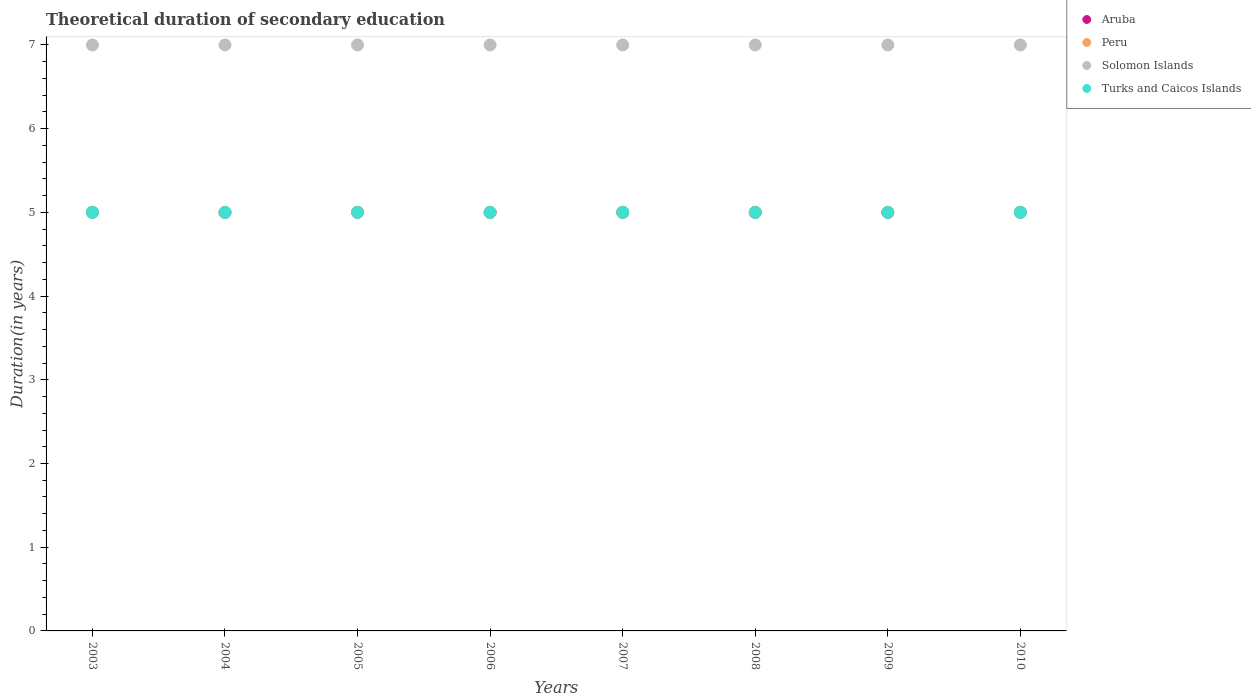How many different coloured dotlines are there?
Provide a short and direct response. 4. What is the total theoretical duration of secondary education in Turks and Caicos Islands in 2007?
Your answer should be compact. 5. Across all years, what is the maximum total theoretical duration of secondary education in Turks and Caicos Islands?
Your response must be concise. 5. Across all years, what is the minimum total theoretical duration of secondary education in Peru?
Ensure brevity in your answer.  5. In which year was the total theoretical duration of secondary education in Solomon Islands maximum?
Your answer should be compact. 2003. What is the total total theoretical duration of secondary education in Peru in the graph?
Offer a very short reply. 40. What is the difference between the total theoretical duration of secondary education in Turks and Caicos Islands in 2003 and that in 2007?
Keep it short and to the point. 0. What is the average total theoretical duration of secondary education in Peru per year?
Your response must be concise. 5. What is the ratio of the total theoretical duration of secondary education in Aruba in 2003 to that in 2006?
Provide a succinct answer. 1. Is it the case that in every year, the sum of the total theoretical duration of secondary education in Peru and total theoretical duration of secondary education in Turks and Caicos Islands  is greater than the sum of total theoretical duration of secondary education in Solomon Islands and total theoretical duration of secondary education in Aruba?
Your answer should be very brief. No. Does the total theoretical duration of secondary education in Solomon Islands monotonically increase over the years?
Your answer should be compact. No. Is the total theoretical duration of secondary education in Peru strictly greater than the total theoretical duration of secondary education in Aruba over the years?
Your answer should be compact. No. Is the total theoretical duration of secondary education in Solomon Islands strictly less than the total theoretical duration of secondary education in Peru over the years?
Keep it short and to the point. No. How many dotlines are there?
Provide a short and direct response. 4. How many years are there in the graph?
Keep it short and to the point. 8. What is the difference between two consecutive major ticks on the Y-axis?
Your answer should be very brief. 1. Are the values on the major ticks of Y-axis written in scientific E-notation?
Your answer should be compact. No. Where does the legend appear in the graph?
Give a very brief answer. Top right. How many legend labels are there?
Provide a short and direct response. 4. What is the title of the graph?
Offer a very short reply. Theoretical duration of secondary education. Does "High income" appear as one of the legend labels in the graph?
Keep it short and to the point. No. What is the label or title of the Y-axis?
Your answer should be compact. Duration(in years). What is the Duration(in years) of Aruba in 2003?
Your answer should be very brief. 5. What is the Duration(in years) of Solomon Islands in 2003?
Your answer should be very brief. 7. What is the Duration(in years) of Turks and Caicos Islands in 2003?
Offer a terse response. 5. What is the Duration(in years) in Peru in 2004?
Offer a very short reply. 5. What is the Duration(in years) in Turks and Caicos Islands in 2004?
Provide a short and direct response. 5. What is the Duration(in years) of Aruba in 2005?
Offer a very short reply. 5. What is the Duration(in years) in Peru in 2005?
Provide a short and direct response. 5. What is the Duration(in years) in Solomon Islands in 2005?
Make the answer very short. 7. What is the Duration(in years) of Turks and Caicos Islands in 2005?
Keep it short and to the point. 5. What is the Duration(in years) in Aruba in 2006?
Your response must be concise. 5. What is the Duration(in years) of Peru in 2006?
Keep it short and to the point. 5. What is the Duration(in years) of Turks and Caicos Islands in 2006?
Ensure brevity in your answer.  5. What is the Duration(in years) of Solomon Islands in 2007?
Ensure brevity in your answer.  7. What is the Duration(in years) of Peru in 2008?
Keep it short and to the point. 5. What is the Duration(in years) in Solomon Islands in 2008?
Provide a short and direct response. 7. What is the Duration(in years) of Turks and Caicos Islands in 2008?
Provide a short and direct response. 5. What is the Duration(in years) of Peru in 2009?
Offer a terse response. 5. What is the Duration(in years) of Solomon Islands in 2009?
Offer a very short reply. 7. What is the Duration(in years) in Turks and Caicos Islands in 2009?
Ensure brevity in your answer.  5. What is the Duration(in years) of Peru in 2010?
Offer a terse response. 5. What is the Duration(in years) in Solomon Islands in 2010?
Offer a terse response. 7. What is the Duration(in years) of Turks and Caicos Islands in 2010?
Provide a short and direct response. 5. Across all years, what is the maximum Duration(in years) of Aruba?
Offer a very short reply. 5. Across all years, what is the maximum Duration(in years) in Peru?
Your answer should be very brief. 5. Across all years, what is the maximum Duration(in years) in Turks and Caicos Islands?
Offer a very short reply. 5. Across all years, what is the minimum Duration(in years) of Peru?
Provide a short and direct response. 5. Across all years, what is the minimum Duration(in years) of Solomon Islands?
Offer a terse response. 7. What is the total Duration(in years) of Peru in the graph?
Provide a short and direct response. 40. What is the difference between the Duration(in years) in Aruba in 2003 and that in 2004?
Provide a short and direct response. 0. What is the difference between the Duration(in years) of Solomon Islands in 2003 and that in 2004?
Provide a short and direct response. 0. What is the difference between the Duration(in years) in Aruba in 2003 and that in 2005?
Make the answer very short. 0. What is the difference between the Duration(in years) in Solomon Islands in 2003 and that in 2005?
Provide a succinct answer. 0. What is the difference between the Duration(in years) of Turks and Caicos Islands in 2003 and that in 2005?
Provide a short and direct response. 0. What is the difference between the Duration(in years) of Aruba in 2003 and that in 2006?
Your answer should be compact. 0. What is the difference between the Duration(in years) in Solomon Islands in 2003 and that in 2006?
Ensure brevity in your answer.  0. What is the difference between the Duration(in years) in Turks and Caicos Islands in 2003 and that in 2006?
Give a very brief answer. 0. What is the difference between the Duration(in years) of Turks and Caicos Islands in 2003 and that in 2007?
Give a very brief answer. 0. What is the difference between the Duration(in years) in Aruba in 2003 and that in 2008?
Offer a terse response. 0. What is the difference between the Duration(in years) of Peru in 2003 and that in 2008?
Make the answer very short. 0. What is the difference between the Duration(in years) in Aruba in 2003 and that in 2009?
Your answer should be very brief. 0. What is the difference between the Duration(in years) of Peru in 2003 and that in 2009?
Your answer should be very brief. 0. What is the difference between the Duration(in years) of Solomon Islands in 2003 and that in 2009?
Provide a short and direct response. 0. What is the difference between the Duration(in years) in Peru in 2003 and that in 2010?
Ensure brevity in your answer.  0. What is the difference between the Duration(in years) of Solomon Islands in 2003 and that in 2010?
Your answer should be very brief. 0. What is the difference between the Duration(in years) of Turks and Caicos Islands in 2003 and that in 2010?
Provide a short and direct response. 0. What is the difference between the Duration(in years) in Aruba in 2004 and that in 2005?
Offer a very short reply. 0. What is the difference between the Duration(in years) in Solomon Islands in 2004 and that in 2005?
Your answer should be very brief. 0. What is the difference between the Duration(in years) of Turks and Caicos Islands in 2004 and that in 2005?
Keep it short and to the point. 0. What is the difference between the Duration(in years) of Aruba in 2004 and that in 2006?
Make the answer very short. 0. What is the difference between the Duration(in years) in Turks and Caicos Islands in 2004 and that in 2006?
Offer a terse response. 0. What is the difference between the Duration(in years) in Aruba in 2004 and that in 2007?
Give a very brief answer. 0. What is the difference between the Duration(in years) in Peru in 2004 and that in 2007?
Provide a short and direct response. 0. What is the difference between the Duration(in years) of Turks and Caicos Islands in 2004 and that in 2007?
Your answer should be compact. 0. What is the difference between the Duration(in years) of Turks and Caicos Islands in 2004 and that in 2008?
Ensure brevity in your answer.  0. What is the difference between the Duration(in years) in Aruba in 2004 and that in 2009?
Your response must be concise. 0. What is the difference between the Duration(in years) in Peru in 2004 and that in 2009?
Offer a very short reply. 0. What is the difference between the Duration(in years) in Turks and Caicos Islands in 2004 and that in 2009?
Keep it short and to the point. 0. What is the difference between the Duration(in years) of Solomon Islands in 2004 and that in 2010?
Give a very brief answer. 0. What is the difference between the Duration(in years) in Aruba in 2005 and that in 2006?
Provide a succinct answer. 0. What is the difference between the Duration(in years) of Solomon Islands in 2005 and that in 2006?
Offer a very short reply. 0. What is the difference between the Duration(in years) in Turks and Caicos Islands in 2005 and that in 2006?
Your answer should be very brief. 0. What is the difference between the Duration(in years) of Peru in 2005 and that in 2007?
Make the answer very short. 0. What is the difference between the Duration(in years) of Aruba in 2005 and that in 2008?
Keep it short and to the point. 0. What is the difference between the Duration(in years) in Turks and Caicos Islands in 2005 and that in 2008?
Provide a succinct answer. 0. What is the difference between the Duration(in years) in Solomon Islands in 2005 and that in 2009?
Provide a succinct answer. 0. What is the difference between the Duration(in years) in Turks and Caicos Islands in 2005 and that in 2009?
Give a very brief answer. 0. What is the difference between the Duration(in years) of Aruba in 2005 and that in 2010?
Provide a succinct answer. 0. What is the difference between the Duration(in years) in Solomon Islands in 2005 and that in 2010?
Provide a short and direct response. 0. What is the difference between the Duration(in years) in Peru in 2006 and that in 2007?
Your answer should be very brief. 0. What is the difference between the Duration(in years) of Solomon Islands in 2006 and that in 2007?
Make the answer very short. 0. What is the difference between the Duration(in years) in Turks and Caicos Islands in 2006 and that in 2007?
Your answer should be very brief. 0. What is the difference between the Duration(in years) in Aruba in 2006 and that in 2008?
Provide a short and direct response. 0. What is the difference between the Duration(in years) of Peru in 2006 and that in 2008?
Make the answer very short. 0. What is the difference between the Duration(in years) of Turks and Caicos Islands in 2006 and that in 2008?
Ensure brevity in your answer.  0. What is the difference between the Duration(in years) of Peru in 2006 and that in 2009?
Your response must be concise. 0. What is the difference between the Duration(in years) in Solomon Islands in 2006 and that in 2009?
Give a very brief answer. 0. What is the difference between the Duration(in years) of Aruba in 2006 and that in 2010?
Ensure brevity in your answer.  0. What is the difference between the Duration(in years) in Peru in 2006 and that in 2010?
Your answer should be very brief. 0. What is the difference between the Duration(in years) in Aruba in 2007 and that in 2008?
Keep it short and to the point. 0. What is the difference between the Duration(in years) of Solomon Islands in 2007 and that in 2008?
Your answer should be very brief. 0. What is the difference between the Duration(in years) of Aruba in 2007 and that in 2009?
Keep it short and to the point. 0. What is the difference between the Duration(in years) of Turks and Caicos Islands in 2007 and that in 2009?
Your answer should be compact. 0. What is the difference between the Duration(in years) of Peru in 2007 and that in 2010?
Offer a terse response. 0. What is the difference between the Duration(in years) in Solomon Islands in 2007 and that in 2010?
Offer a very short reply. 0. What is the difference between the Duration(in years) of Turks and Caicos Islands in 2007 and that in 2010?
Offer a very short reply. 0. What is the difference between the Duration(in years) in Solomon Islands in 2008 and that in 2009?
Your answer should be very brief. 0. What is the difference between the Duration(in years) of Solomon Islands in 2008 and that in 2010?
Give a very brief answer. 0. What is the difference between the Duration(in years) of Aruba in 2009 and that in 2010?
Your answer should be very brief. 0. What is the difference between the Duration(in years) in Aruba in 2003 and the Duration(in years) in Peru in 2004?
Provide a short and direct response. 0. What is the difference between the Duration(in years) of Aruba in 2003 and the Duration(in years) of Peru in 2005?
Your answer should be very brief. 0. What is the difference between the Duration(in years) in Aruba in 2003 and the Duration(in years) in Turks and Caicos Islands in 2005?
Provide a short and direct response. 0. What is the difference between the Duration(in years) of Aruba in 2003 and the Duration(in years) of Peru in 2006?
Your answer should be compact. 0. What is the difference between the Duration(in years) in Aruba in 2003 and the Duration(in years) in Solomon Islands in 2006?
Offer a terse response. -2. What is the difference between the Duration(in years) of Peru in 2003 and the Duration(in years) of Solomon Islands in 2006?
Provide a succinct answer. -2. What is the difference between the Duration(in years) of Peru in 2003 and the Duration(in years) of Turks and Caicos Islands in 2006?
Give a very brief answer. 0. What is the difference between the Duration(in years) of Solomon Islands in 2003 and the Duration(in years) of Turks and Caicos Islands in 2006?
Your answer should be very brief. 2. What is the difference between the Duration(in years) of Peru in 2003 and the Duration(in years) of Turks and Caicos Islands in 2007?
Your answer should be compact. 0. What is the difference between the Duration(in years) of Aruba in 2003 and the Duration(in years) of Peru in 2008?
Your answer should be compact. 0. What is the difference between the Duration(in years) of Aruba in 2003 and the Duration(in years) of Turks and Caicos Islands in 2008?
Your answer should be compact. 0. What is the difference between the Duration(in years) in Peru in 2003 and the Duration(in years) in Solomon Islands in 2008?
Give a very brief answer. -2. What is the difference between the Duration(in years) in Aruba in 2003 and the Duration(in years) in Solomon Islands in 2009?
Make the answer very short. -2. What is the difference between the Duration(in years) in Peru in 2003 and the Duration(in years) in Solomon Islands in 2009?
Provide a short and direct response. -2. What is the difference between the Duration(in years) in Aruba in 2003 and the Duration(in years) in Peru in 2010?
Provide a succinct answer. 0. What is the difference between the Duration(in years) in Aruba in 2003 and the Duration(in years) in Turks and Caicos Islands in 2010?
Your answer should be compact. 0. What is the difference between the Duration(in years) of Peru in 2003 and the Duration(in years) of Turks and Caicos Islands in 2010?
Provide a short and direct response. 0. What is the difference between the Duration(in years) in Solomon Islands in 2003 and the Duration(in years) in Turks and Caicos Islands in 2010?
Provide a succinct answer. 2. What is the difference between the Duration(in years) in Aruba in 2004 and the Duration(in years) in Solomon Islands in 2005?
Give a very brief answer. -2. What is the difference between the Duration(in years) of Aruba in 2004 and the Duration(in years) of Turks and Caicos Islands in 2005?
Your answer should be very brief. 0. What is the difference between the Duration(in years) of Aruba in 2004 and the Duration(in years) of Peru in 2006?
Give a very brief answer. 0. What is the difference between the Duration(in years) of Aruba in 2004 and the Duration(in years) of Turks and Caicos Islands in 2006?
Ensure brevity in your answer.  0. What is the difference between the Duration(in years) of Peru in 2004 and the Duration(in years) of Solomon Islands in 2006?
Your answer should be very brief. -2. What is the difference between the Duration(in years) of Peru in 2004 and the Duration(in years) of Turks and Caicos Islands in 2006?
Offer a very short reply. 0. What is the difference between the Duration(in years) of Solomon Islands in 2004 and the Duration(in years) of Turks and Caicos Islands in 2006?
Give a very brief answer. 2. What is the difference between the Duration(in years) of Aruba in 2004 and the Duration(in years) of Peru in 2007?
Keep it short and to the point. 0. What is the difference between the Duration(in years) in Aruba in 2004 and the Duration(in years) in Solomon Islands in 2007?
Offer a very short reply. -2. What is the difference between the Duration(in years) of Peru in 2004 and the Duration(in years) of Solomon Islands in 2007?
Offer a very short reply. -2. What is the difference between the Duration(in years) of Peru in 2004 and the Duration(in years) of Turks and Caicos Islands in 2007?
Keep it short and to the point. 0. What is the difference between the Duration(in years) of Solomon Islands in 2004 and the Duration(in years) of Turks and Caicos Islands in 2007?
Provide a succinct answer. 2. What is the difference between the Duration(in years) of Peru in 2004 and the Duration(in years) of Turks and Caicos Islands in 2008?
Ensure brevity in your answer.  0. What is the difference between the Duration(in years) in Aruba in 2004 and the Duration(in years) in Peru in 2010?
Offer a very short reply. 0. What is the difference between the Duration(in years) of Aruba in 2004 and the Duration(in years) of Solomon Islands in 2010?
Offer a terse response. -2. What is the difference between the Duration(in years) of Aruba in 2004 and the Duration(in years) of Turks and Caicos Islands in 2010?
Give a very brief answer. 0. What is the difference between the Duration(in years) in Peru in 2004 and the Duration(in years) in Turks and Caicos Islands in 2010?
Give a very brief answer. 0. What is the difference between the Duration(in years) of Peru in 2005 and the Duration(in years) of Solomon Islands in 2006?
Make the answer very short. -2. What is the difference between the Duration(in years) of Peru in 2005 and the Duration(in years) of Turks and Caicos Islands in 2006?
Your answer should be compact. 0. What is the difference between the Duration(in years) in Aruba in 2005 and the Duration(in years) in Turks and Caicos Islands in 2007?
Provide a short and direct response. 0. What is the difference between the Duration(in years) of Peru in 2005 and the Duration(in years) of Solomon Islands in 2007?
Ensure brevity in your answer.  -2. What is the difference between the Duration(in years) of Solomon Islands in 2005 and the Duration(in years) of Turks and Caicos Islands in 2007?
Your answer should be very brief. 2. What is the difference between the Duration(in years) of Aruba in 2005 and the Duration(in years) of Peru in 2008?
Ensure brevity in your answer.  0. What is the difference between the Duration(in years) of Aruba in 2005 and the Duration(in years) of Peru in 2009?
Your response must be concise. 0. What is the difference between the Duration(in years) in Aruba in 2005 and the Duration(in years) in Solomon Islands in 2009?
Your answer should be very brief. -2. What is the difference between the Duration(in years) of Peru in 2005 and the Duration(in years) of Turks and Caicos Islands in 2009?
Your answer should be very brief. 0. What is the difference between the Duration(in years) of Solomon Islands in 2005 and the Duration(in years) of Turks and Caicos Islands in 2009?
Give a very brief answer. 2. What is the difference between the Duration(in years) of Aruba in 2005 and the Duration(in years) of Solomon Islands in 2010?
Make the answer very short. -2. What is the difference between the Duration(in years) in Peru in 2005 and the Duration(in years) in Solomon Islands in 2010?
Offer a very short reply. -2. What is the difference between the Duration(in years) of Peru in 2005 and the Duration(in years) of Turks and Caicos Islands in 2010?
Provide a succinct answer. 0. What is the difference between the Duration(in years) in Solomon Islands in 2005 and the Duration(in years) in Turks and Caicos Islands in 2010?
Make the answer very short. 2. What is the difference between the Duration(in years) in Aruba in 2006 and the Duration(in years) in Peru in 2007?
Your response must be concise. 0. What is the difference between the Duration(in years) in Aruba in 2006 and the Duration(in years) in Solomon Islands in 2007?
Provide a short and direct response. -2. What is the difference between the Duration(in years) of Peru in 2006 and the Duration(in years) of Solomon Islands in 2007?
Your response must be concise. -2. What is the difference between the Duration(in years) in Peru in 2006 and the Duration(in years) in Turks and Caicos Islands in 2007?
Offer a very short reply. 0. What is the difference between the Duration(in years) in Solomon Islands in 2006 and the Duration(in years) in Turks and Caicos Islands in 2007?
Ensure brevity in your answer.  2. What is the difference between the Duration(in years) in Peru in 2006 and the Duration(in years) in Turks and Caicos Islands in 2008?
Offer a terse response. 0. What is the difference between the Duration(in years) of Aruba in 2006 and the Duration(in years) of Peru in 2009?
Make the answer very short. 0. What is the difference between the Duration(in years) of Aruba in 2006 and the Duration(in years) of Solomon Islands in 2009?
Ensure brevity in your answer.  -2. What is the difference between the Duration(in years) of Peru in 2006 and the Duration(in years) of Solomon Islands in 2009?
Your answer should be compact. -2. What is the difference between the Duration(in years) in Peru in 2006 and the Duration(in years) in Turks and Caicos Islands in 2009?
Your response must be concise. 0. What is the difference between the Duration(in years) of Solomon Islands in 2006 and the Duration(in years) of Turks and Caicos Islands in 2009?
Your answer should be very brief. 2. What is the difference between the Duration(in years) in Aruba in 2007 and the Duration(in years) in Solomon Islands in 2008?
Keep it short and to the point. -2. What is the difference between the Duration(in years) of Peru in 2007 and the Duration(in years) of Solomon Islands in 2008?
Your answer should be very brief. -2. What is the difference between the Duration(in years) of Solomon Islands in 2007 and the Duration(in years) of Turks and Caicos Islands in 2008?
Your response must be concise. 2. What is the difference between the Duration(in years) of Aruba in 2007 and the Duration(in years) of Peru in 2009?
Keep it short and to the point. 0. What is the difference between the Duration(in years) in Aruba in 2007 and the Duration(in years) in Solomon Islands in 2009?
Your response must be concise. -2. What is the difference between the Duration(in years) in Solomon Islands in 2007 and the Duration(in years) in Turks and Caicos Islands in 2009?
Ensure brevity in your answer.  2. What is the difference between the Duration(in years) of Aruba in 2007 and the Duration(in years) of Peru in 2010?
Ensure brevity in your answer.  0. What is the difference between the Duration(in years) in Peru in 2007 and the Duration(in years) in Turks and Caicos Islands in 2010?
Ensure brevity in your answer.  0. What is the difference between the Duration(in years) of Solomon Islands in 2007 and the Duration(in years) of Turks and Caicos Islands in 2010?
Ensure brevity in your answer.  2. What is the difference between the Duration(in years) in Aruba in 2008 and the Duration(in years) in Peru in 2009?
Make the answer very short. 0. What is the difference between the Duration(in years) in Aruba in 2008 and the Duration(in years) in Turks and Caicos Islands in 2009?
Provide a short and direct response. 0. What is the difference between the Duration(in years) of Aruba in 2008 and the Duration(in years) of Peru in 2010?
Offer a terse response. 0. What is the difference between the Duration(in years) in Aruba in 2008 and the Duration(in years) in Turks and Caicos Islands in 2010?
Your response must be concise. 0. What is the difference between the Duration(in years) of Peru in 2008 and the Duration(in years) of Turks and Caicos Islands in 2010?
Ensure brevity in your answer.  0. What is the difference between the Duration(in years) in Aruba in 2009 and the Duration(in years) in Peru in 2010?
Your answer should be very brief. 0. What is the difference between the Duration(in years) in Aruba in 2009 and the Duration(in years) in Turks and Caicos Islands in 2010?
Make the answer very short. 0. What is the difference between the Duration(in years) in Peru in 2009 and the Duration(in years) in Turks and Caicos Islands in 2010?
Provide a succinct answer. 0. What is the difference between the Duration(in years) in Solomon Islands in 2009 and the Duration(in years) in Turks and Caicos Islands in 2010?
Provide a short and direct response. 2. In the year 2003, what is the difference between the Duration(in years) in Aruba and Duration(in years) in Turks and Caicos Islands?
Your response must be concise. 0. In the year 2004, what is the difference between the Duration(in years) in Aruba and Duration(in years) in Peru?
Offer a terse response. 0. In the year 2004, what is the difference between the Duration(in years) in Aruba and Duration(in years) in Solomon Islands?
Your answer should be very brief. -2. In the year 2004, what is the difference between the Duration(in years) in Solomon Islands and Duration(in years) in Turks and Caicos Islands?
Your response must be concise. 2. In the year 2005, what is the difference between the Duration(in years) of Aruba and Duration(in years) of Peru?
Keep it short and to the point. 0. In the year 2005, what is the difference between the Duration(in years) of Aruba and Duration(in years) of Solomon Islands?
Provide a short and direct response. -2. In the year 2005, what is the difference between the Duration(in years) in Solomon Islands and Duration(in years) in Turks and Caicos Islands?
Keep it short and to the point. 2. In the year 2006, what is the difference between the Duration(in years) of Aruba and Duration(in years) of Peru?
Keep it short and to the point. 0. In the year 2006, what is the difference between the Duration(in years) of Peru and Duration(in years) of Solomon Islands?
Ensure brevity in your answer.  -2. In the year 2007, what is the difference between the Duration(in years) of Aruba and Duration(in years) of Peru?
Keep it short and to the point. 0. In the year 2007, what is the difference between the Duration(in years) of Aruba and Duration(in years) of Solomon Islands?
Your response must be concise. -2. In the year 2007, what is the difference between the Duration(in years) in Aruba and Duration(in years) in Turks and Caicos Islands?
Offer a terse response. 0. In the year 2007, what is the difference between the Duration(in years) of Peru and Duration(in years) of Turks and Caicos Islands?
Provide a short and direct response. 0. In the year 2007, what is the difference between the Duration(in years) of Solomon Islands and Duration(in years) of Turks and Caicos Islands?
Provide a short and direct response. 2. In the year 2008, what is the difference between the Duration(in years) of Aruba and Duration(in years) of Peru?
Ensure brevity in your answer.  0. In the year 2008, what is the difference between the Duration(in years) in Aruba and Duration(in years) in Solomon Islands?
Your answer should be compact. -2. In the year 2008, what is the difference between the Duration(in years) in Aruba and Duration(in years) in Turks and Caicos Islands?
Make the answer very short. 0. In the year 2008, what is the difference between the Duration(in years) in Peru and Duration(in years) in Solomon Islands?
Provide a short and direct response. -2. In the year 2009, what is the difference between the Duration(in years) of Aruba and Duration(in years) of Peru?
Offer a very short reply. 0. In the year 2010, what is the difference between the Duration(in years) in Aruba and Duration(in years) in Peru?
Make the answer very short. 0. In the year 2010, what is the difference between the Duration(in years) in Aruba and Duration(in years) in Turks and Caicos Islands?
Offer a very short reply. 0. In the year 2010, what is the difference between the Duration(in years) of Peru and Duration(in years) of Turks and Caicos Islands?
Your answer should be compact. 0. In the year 2010, what is the difference between the Duration(in years) of Solomon Islands and Duration(in years) of Turks and Caicos Islands?
Provide a succinct answer. 2. What is the ratio of the Duration(in years) in Solomon Islands in 2003 to that in 2004?
Keep it short and to the point. 1. What is the ratio of the Duration(in years) in Turks and Caicos Islands in 2003 to that in 2004?
Offer a very short reply. 1. What is the ratio of the Duration(in years) of Peru in 2003 to that in 2005?
Make the answer very short. 1. What is the ratio of the Duration(in years) in Turks and Caicos Islands in 2003 to that in 2005?
Keep it short and to the point. 1. What is the ratio of the Duration(in years) in Aruba in 2003 to that in 2006?
Your answer should be compact. 1. What is the ratio of the Duration(in years) in Peru in 2003 to that in 2007?
Give a very brief answer. 1. What is the ratio of the Duration(in years) of Solomon Islands in 2003 to that in 2007?
Make the answer very short. 1. What is the ratio of the Duration(in years) in Solomon Islands in 2003 to that in 2008?
Your answer should be very brief. 1. What is the ratio of the Duration(in years) of Turks and Caicos Islands in 2003 to that in 2008?
Provide a short and direct response. 1. What is the ratio of the Duration(in years) in Peru in 2003 to that in 2009?
Offer a terse response. 1. What is the ratio of the Duration(in years) of Solomon Islands in 2003 to that in 2009?
Provide a short and direct response. 1. What is the ratio of the Duration(in years) in Aruba in 2003 to that in 2010?
Your answer should be compact. 1. What is the ratio of the Duration(in years) in Peru in 2003 to that in 2010?
Your answer should be compact. 1. What is the ratio of the Duration(in years) in Solomon Islands in 2003 to that in 2010?
Give a very brief answer. 1. What is the ratio of the Duration(in years) of Turks and Caicos Islands in 2003 to that in 2010?
Offer a very short reply. 1. What is the ratio of the Duration(in years) of Aruba in 2004 to that in 2005?
Offer a terse response. 1. What is the ratio of the Duration(in years) of Turks and Caicos Islands in 2004 to that in 2005?
Your answer should be very brief. 1. What is the ratio of the Duration(in years) in Aruba in 2004 to that in 2006?
Your answer should be very brief. 1. What is the ratio of the Duration(in years) of Turks and Caicos Islands in 2004 to that in 2006?
Ensure brevity in your answer.  1. What is the ratio of the Duration(in years) in Aruba in 2004 to that in 2007?
Ensure brevity in your answer.  1. What is the ratio of the Duration(in years) in Turks and Caicos Islands in 2004 to that in 2007?
Give a very brief answer. 1. What is the ratio of the Duration(in years) in Peru in 2004 to that in 2008?
Provide a succinct answer. 1. What is the ratio of the Duration(in years) of Solomon Islands in 2004 to that in 2008?
Ensure brevity in your answer.  1. What is the ratio of the Duration(in years) of Peru in 2004 to that in 2009?
Make the answer very short. 1. What is the ratio of the Duration(in years) of Turks and Caicos Islands in 2004 to that in 2009?
Give a very brief answer. 1. What is the ratio of the Duration(in years) of Peru in 2004 to that in 2010?
Keep it short and to the point. 1. What is the ratio of the Duration(in years) in Solomon Islands in 2004 to that in 2010?
Your answer should be compact. 1. What is the ratio of the Duration(in years) in Turks and Caicos Islands in 2004 to that in 2010?
Your response must be concise. 1. What is the ratio of the Duration(in years) of Solomon Islands in 2005 to that in 2006?
Offer a very short reply. 1. What is the ratio of the Duration(in years) in Solomon Islands in 2005 to that in 2007?
Ensure brevity in your answer.  1. What is the ratio of the Duration(in years) in Turks and Caicos Islands in 2005 to that in 2007?
Your response must be concise. 1. What is the ratio of the Duration(in years) of Aruba in 2005 to that in 2008?
Ensure brevity in your answer.  1. What is the ratio of the Duration(in years) of Peru in 2005 to that in 2009?
Offer a very short reply. 1. What is the ratio of the Duration(in years) of Turks and Caicos Islands in 2005 to that in 2009?
Offer a very short reply. 1. What is the ratio of the Duration(in years) in Solomon Islands in 2005 to that in 2010?
Your answer should be compact. 1. What is the ratio of the Duration(in years) of Aruba in 2006 to that in 2007?
Your answer should be compact. 1. What is the ratio of the Duration(in years) in Peru in 2006 to that in 2007?
Offer a very short reply. 1. What is the ratio of the Duration(in years) in Turks and Caicos Islands in 2006 to that in 2007?
Your answer should be compact. 1. What is the ratio of the Duration(in years) in Aruba in 2006 to that in 2008?
Provide a succinct answer. 1. What is the ratio of the Duration(in years) of Solomon Islands in 2006 to that in 2008?
Your response must be concise. 1. What is the ratio of the Duration(in years) of Turks and Caicos Islands in 2006 to that in 2008?
Keep it short and to the point. 1. What is the ratio of the Duration(in years) of Peru in 2006 to that in 2009?
Keep it short and to the point. 1. What is the ratio of the Duration(in years) in Turks and Caicos Islands in 2006 to that in 2009?
Your answer should be compact. 1. What is the ratio of the Duration(in years) of Peru in 2006 to that in 2010?
Offer a terse response. 1. What is the ratio of the Duration(in years) of Aruba in 2007 to that in 2008?
Keep it short and to the point. 1. What is the ratio of the Duration(in years) in Peru in 2007 to that in 2008?
Your answer should be very brief. 1. What is the ratio of the Duration(in years) of Aruba in 2007 to that in 2009?
Make the answer very short. 1. What is the ratio of the Duration(in years) in Solomon Islands in 2007 to that in 2009?
Your response must be concise. 1. What is the ratio of the Duration(in years) of Peru in 2007 to that in 2010?
Your answer should be compact. 1. What is the ratio of the Duration(in years) of Aruba in 2008 to that in 2009?
Your response must be concise. 1. What is the ratio of the Duration(in years) of Peru in 2008 to that in 2009?
Your response must be concise. 1. What is the ratio of the Duration(in years) in Solomon Islands in 2008 to that in 2009?
Your answer should be compact. 1. What is the ratio of the Duration(in years) in Peru in 2008 to that in 2010?
Give a very brief answer. 1. What is the ratio of the Duration(in years) in Solomon Islands in 2008 to that in 2010?
Your answer should be compact. 1. What is the ratio of the Duration(in years) in Turks and Caicos Islands in 2008 to that in 2010?
Your response must be concise. 1. What is the ratio of the Duration(in years) of Aruba in 2009 to that in 2010?
Give a very brief answer. 1. What is the ratio of the Duration(in years) of Peru in 2009 to that in 2010?
Provide a succinct answer. 1. What is the ratio of the Duration(in years) in Solomon Islands in 2009 to that in 2010?
Make the answer very short. 1. What is the difference between the highest and the second highest Duration(in years) in Aruba?
Offer a terse response. 0. What is the difference between the highest and the second highest Duration(in years) of Solomon Islands?
Offer a very short reply. 0. What is the difference between the highest and the second highest Duration(in years) in Turks and Caicos Islands?
Your answer should be compact. 0. What is the difference between the highest and the lowest Duration(in years) in Solomon Islands?
Give a very brief answer. 0. What is the difference between the highest and the lowest Duration(in years) in Turks and Caicos Islands?
Your answer should be compact. 0. 